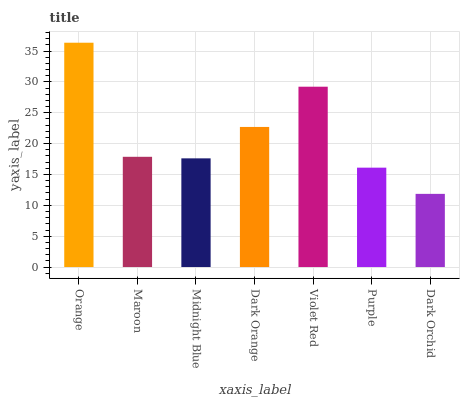Is Dark Orchid the minimum?
Answer yes or no. Yes. Is Orange the maximum?
Answer yes or no. Yes. Is Maroon the minimum?
Answer yes or no. No. Is Maroon the maximum?
Answer yes or no. No. Is Orange greater than Maroon?
Answer yes or no. Yes. Is Maroon less than Orange?
Answer yes or no. Yes. Is Maroon greater than Orange?
Answer yes or no. No. Is Orange less than Maroon?
Answer yes or no. No. Is Maroon the high median?
Answer yes or no. Yes. Is Maroon the low median?
Answer yes or no. Yes. Is Midnight Blue the high median?
Answer yes or no. No. Is Dark Orange the low median?
Answer yes or no. No. 